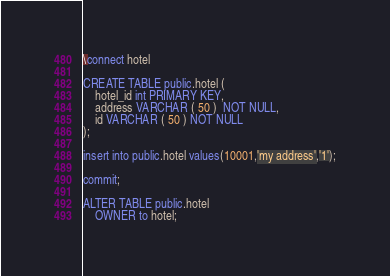Convert code to text. <code><loc_0><loc_0><loc_500><loc_500><_SQL_>
\connect hotel

CREATE TABLE public.hotel (
	hotel_id int PRIMARY KEY,
	address VARCHAR ( 50 )  NOT NULL,
	id VARCHAR ( 50 ) NOT NULL
);

insert into public.hotel values(10001,'my address','1');

commit;

ALTER TABLE public.hotel
    OWNER to hotel;
</code> 